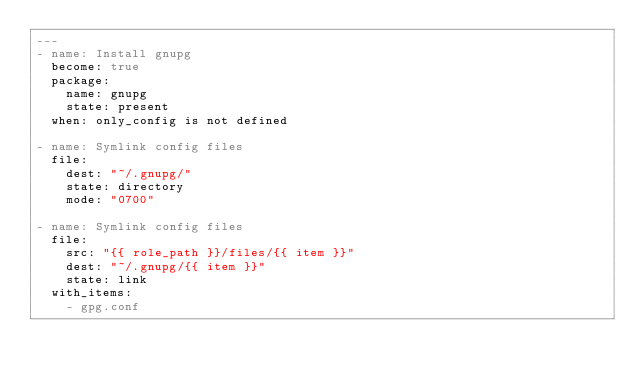Convert code to text. <code><loc_0><loc_0><loc_500><loc_500><_YAML_>---
- name: Install gnupg
  become: true
  package:
    name: gnupg
    state: present
  when: only_config is not defined

- name: Symlink config files
  file:
    dest: "~/.gnupg/"
    state: directory
    mode: "0700"

- name: Symlink config files
  file:
    src: "{{ role_path }}/files/{{ item }}"
    dest: "~/.gnupg/{{ item }}"
    state: link
  with_items:
    - gpg.conf
</code> 